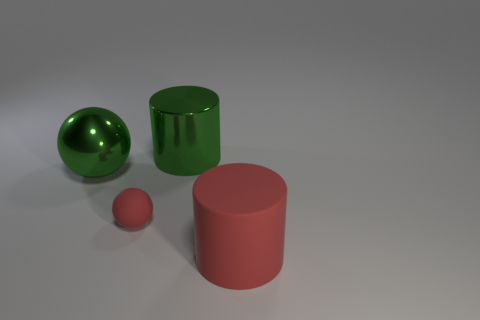Add 2 big red cylinders. How many objects exist? 6 Add 3 green metal spheres. How many green metal spheres are left? 4 Add 2 big matte cylinders. How many big matte cylinders exist? 3 Subtract 0 brown blocks. How many objects are left? 4 Subtract all small blue objects. Subtract all large green shiny cylinders. How many objects are left? 3 